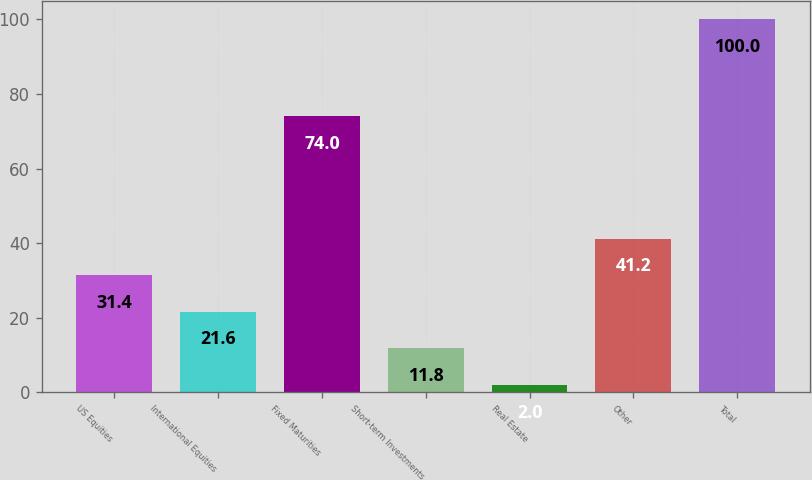Convert chart. <chart><loc_0><loc_0><loc_500><loc_500><bar_chart><fcel>US Equities<fcel>International Equities<fcel>Fixed Maturities<fcel>Short-term Investments<fcel>Real Estate<fcel>Other<fcel>Total<nl><fcel>31.4<fcel>21.6<fcel>74<fcel>11.8<fcel>2<fcel>41.2<fcel>100<nl></chart> 